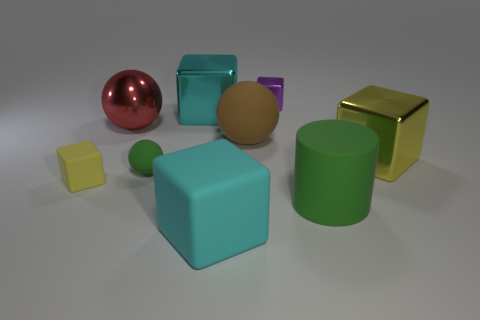Is the color of the large cylinder in front of the yellow metal thing the same as the small matte ball?
Offer a terse response. Yes. There is a shiny block that is both in front of the small purple object and to the left of the big green thing; what is its size?
Your answer should be compact. Large. How many tiny objects are either green cylinders or brown matte things?
Provide a short and direct response. 0. What shape is the cyan object behind the tiny matte block?
Ensure brevity in your answer.  Cube. What number of small purple metal objects are there?
Your answer should be compact. 1. Do the red ball and the green cylinder have the same material?
Provide a short and direct response. No. Are there more large green matte things that are behind the red thing than large red cylinders?
Make the answer very short. No. How many objects are either red shiny blocks or big metallic blocks that are in front of the cyan metal cube?
Make the answer very short. 1. Are there more small yellow objects to the left of the big green rubber cylinder than small green objects that are in front of the large yellow metallic object?
Your answer should be compact. No. What material is the big cyan cube that is in front of the big metal block that is right of the metal block that is behind the cyan shiny cube?
Your answer should be compact. Rubber. 